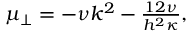<formula> <loc_0><loc_0><loc_500><loc_500>\begin{array} { r } { \mu _ { \perp } = - \nu k ^ { 2 } - \frac { 1 2 \nu } { h ^ { 2 } \kappa } , } \end{array}</formula> 